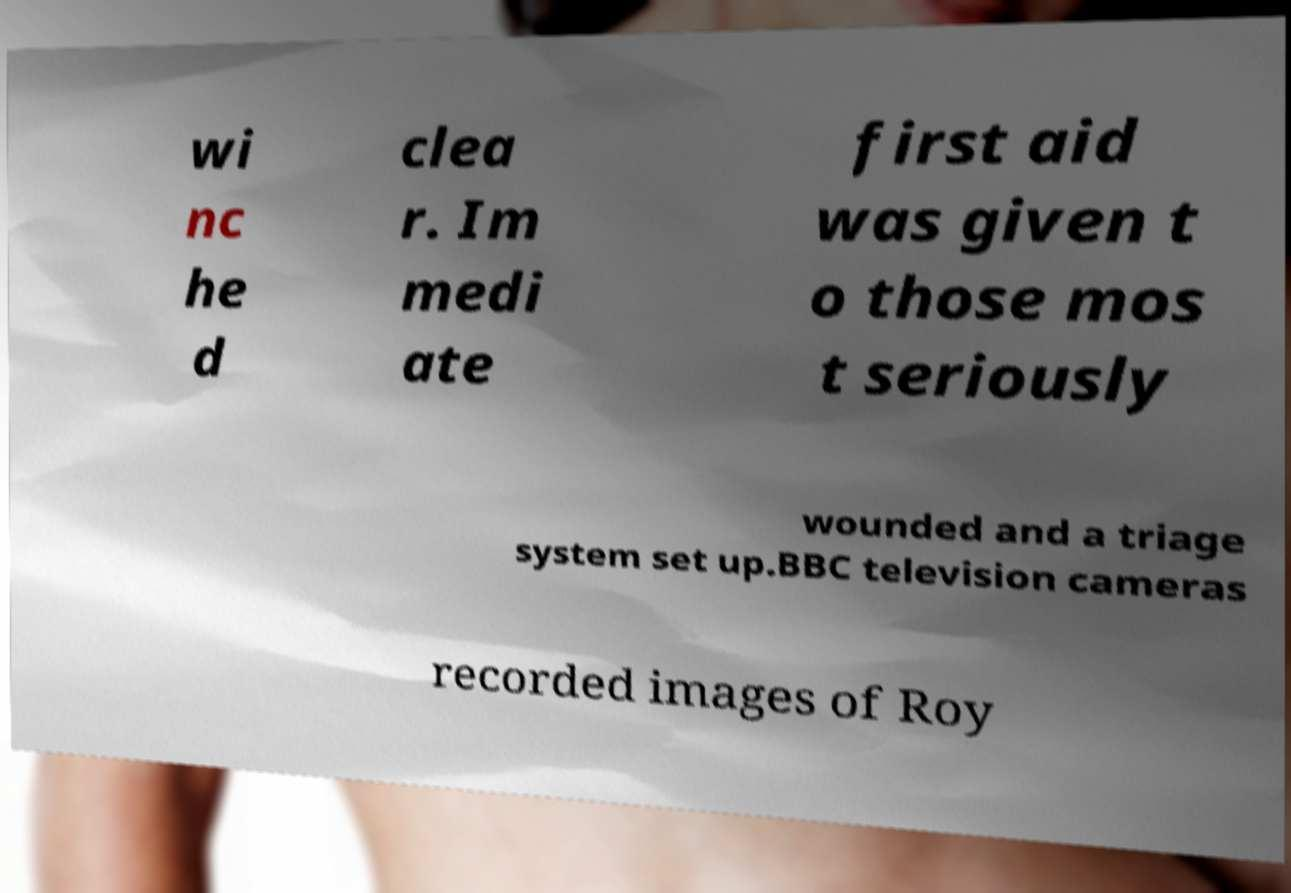What messages or text are displayed in this image? I need them in a readable, typed format. wi nc he d clea r. Im medi ate first aid was given t o those mos t seriously wounded and a triage system set up.BBC television cameras recorded images of Roy 